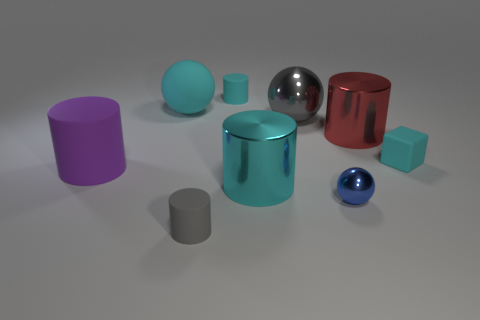Subtract all yellow cylinders. Subtract all gray balls. How many cylinders are left? 5 Add 1 cyan metal cylinders. How many objects exist? 10 Subtract all cubes. How many objects are left? 8 Add 8 gray objects. How many gray objects are left? 10 Add 5 tiny metal balls. How many tiny metal balls exist? 6 Subtract 0 purple blocks. How many objects are left? 9 Subtract all big rubber spheres. Subtract all gray spheres. How many objects are left? 7 